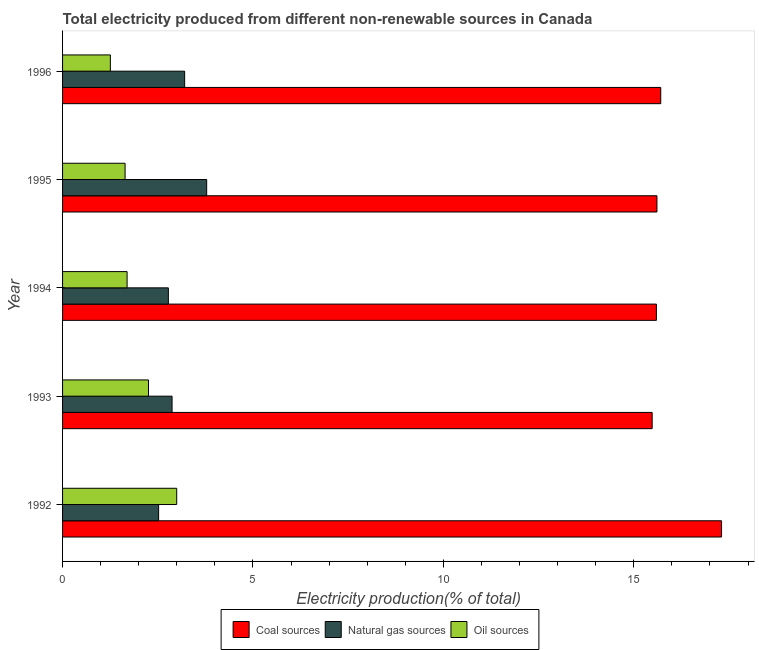How many groups of bars are there?
Offer a very short reply. 5. Are the number of bars on each tick of the Y-axis equal?
Give a very brief answer. Yes. How many bars are there on the 4th tick from the bottom?
Provide a short and direct response. 3. What is the label of the 3rd group of bars from the top?
Ensure brevity in your answer.  1994. In how many cases, is the number of bars for a given year not equal to the number of legend labels?
Make the answer very short. 0. What is the percentage of electricity produced by natural gas in 1996?
Provide a succinct answer. 3.21. Across all years, what is the maximum percentage of electricity produced by natural gas?
Provide a succinct answer. 3.78. Across all years, what is the minimum percentage of electricity produced by natural gas?
Make the answer very short. 2.52. In which year was the percentage of electricity produced by natural gas maximum?
Keep it short and to the point. 1995. What is the total percentage of electricity produced by natural gas in the graph?
Offer a very short reply. 15.16. What is the difference between the percentage of electricity produced by oil sources in 1992 and that in 1993?
Offer a very short reply. 0.74. What is the difference between the percentage of electricity produced by oil sources in 1994 and the percentage of electricity produced by natural gas in 1995?
Your answer should be compact. -2.09. What is the average percentage of electricity produced by oil sources per year?
Your answer should be very brief. 1.97. In the year 1993, what is the difference between the percentage of electricity produced by natural gas and percentage of electricity produced by coal?
Ensure brevity in your answer.  -12.61. What is the ratio of the percentage of electricity produced by natural gas in 1992 to that in 1996?
Your answer should be very brief. 0.79. What is the difference between the highest and the second highest percentage of electricity produced by oil sources?
Make the answer very short. 0.74. What is the difference between the highest and the lowest percentage of electricity produced by natural gas?
Keep it short and to the point. 1.26. In how many years, is the percentage of electricity produced by coal greater than the average percentage of electricity produced by coal taken over all years?
Your answer should be compact. 1. What does the 1st bar from the top in 1993 represents?
Offer a very short reply. Oil sources. What does the 3rd bar from the bottom in 1995 represents?
Offer a very short reply. Oil sources. Is it the case that in every year, the sum of the percentage of electricity produced by coal and percentage of electricity produced by natural gas is greater than the percentage of electricity produced by oil sources?
Ensure brevity in your answer.  Yes. How many bars are there?
Your answer should be compact. 15. What is the difference between two consecutive major ticks on the X-axis?
Your answer should be very brief. 5. Does the graph contain grids?
Offer a very short reply. No. How are the legend labels stacked?
Ensure brevity in your answer.  Horizontal. What is the title of the graph?
Provide a short and direct response. Total electricity produced from different non-renewable sources in Canada. Does "Slovak Republic" appear as one of the legend labels in the graph?
Offer a very short reply. No. What is the label or title of the Y-axis?
Ensure brevity in your answer.  Year. What is the Electricity production(% of total) in Coal sources in 1992?
Provide a short and direct response. 17.3. What is the Electricity production(% of total) in Natural gas sources in 1992?
Your response must be concise. 2.52. What is the Electricity production(% of total) in Oil sources in 1992?
Give a very brief answer. 3. What is the Electricity production(% of total) in Coal sources in 1993?
Offer a terse response. 15.48. What is the Electricity production(% of total) in Natural gas sources in 1993?
Your response must be concise. 2.88. What is the Electricity production(% of total) in Oil sources in 1993?
Make the answer very short. 2.26. What is the Electricity production(% of total) of Coal sources in 1994?
Ensure brevity in your answer.  15.59. What is the Electricity production(% of total) of Natural gas sources in 1994?
Your answer should be compact. 2.78. What is the Electricity production(% of total) of Oil sources in 1994?
Your answer should be compact. 1.69. What is the Electricity production(% of total) in Coal sources in 1995?
Provide a succinct answer. 15.61. What is the Electricity production(% of total) of Natural gas sources in 1995?
Provide a succinct answer. 3.78. What is the Electricity production(% of total) of Oil sources in 1995?
Give a very brief answer. 1.64. What is the Electricity production(% of total) in Coal sources in 1996?
Your response must be concise. 15.71. What is the Electricity production(% of total) of Natural gas sources in 1996?
Give a very brief answer. 3.21. What is the Electricity production(% of total) in Oil sources in 1996?
Offer a terse response. 1.25. Across all years, what is the maximum Electricity production(% of total) in Coal sources?
Provide a short and direct response. 17.3. Across all years, what is the maximum Electricity production(% of total) in Natural gas sources?
Your answer should be compact. 3.78. Across all years, what is the maximum Electricity production(% of total) in Oil sources?
Your response must be concise. 3. Across all years, what is the minimum Electricity production(% of total) of Coal sources?
Offer a terse response. 15.48. Across all years, what is the minimum Electricity production(% of total) of Natural gas sources?
Your answer should be very brief. 2.52. Across all years, what is the minimum Electricity production(% of total) in Oil sources?
Make the answer very short. 1.25. What is the total Electricity production(% of total) in Coal sources in the graph?
Your answer should be very brief. 79.7. What is the total Electricity production(% of total) of Natural gas sources in the graph?
Your response must be concise. 15.16. What is the total Electricity production(% of total) of Oil sources in the graph?
Keep it short and to the point. 9.85. What is the difference between the Electricity production(% of total) in Coal sources in 1992 and that in 1993?
Give a very brief answer. 1.82. What is the difference between the Electricity production(% of total) of Natural gas sources in 1992 and that in 1993?
Make the answer very short. -0.35. What is the difference between the Electricity production(% of total) of Oil sources in 1992 and that in 1993?
Your response must be concise. 0.74. What is the difference between the Electricity production(% of total) of Coal sources in 1992 and that in 1994?
Give a very brief answer. 1.71. What is the difference between the Electricity production(% of total) of Natural gas sources in 1992 and that in 1994?
Provide a succinct answer. -0.26. What is the difference between the Electricity production(% of total) in Oil sources in 1992 and that in 1994?
Your response must be concise. 1.3. What is the difference between the Electricity production(% of total) in Coal sources in 1992 and that in 1995?
Provide a short and direct response. 1.7. What is the difference between the Electricity production(% of total) in Natural gas sources in 1992 and that in 1995?
Provide a short and direct response. -1.26. What is the difference between the Electricity production(% of total) in Oil sources in 1992 and that in 1995?
Offer a terse response. 1.36. What is the difference between the Electricity production(% of total) in Coal sources in 1992 and that in 1996?
Your response must be concise. 1.6. What is the difference between the Electricity production(% of total) of Natural gas sources in 1992 and that in 1996?
Your answer should be compact. -0.68. What is the difference between the Electricity production(% of total) of Oil sources in 1992 and that in 1996?
Ensure brevity in your answer.  1.74. What is the difference between the Electricity production(% of total) in Coal sources in 1993 and that in 1994?
Your answer should be very brief. -0.11. What is the difference between the Electricity production(% of total) in Natural gas sources in 1993 and that in 1994?
Give a very brief answer. 0.1. What is the difference between the Electricity production(% of total) of Oil sources in 1993 and that in 1994?
Provide a short and direct response. 0.56. What is the difference between the Electricity production(% of total) of Coal sources in 1993 and that in 1995?
Offer a terse response. -0.13. What is the difference between the Electricity production(% of total) of Natural gas sources in 1993 and that in 1995?
Your answer should be compact. -0.91. What is the difference between the Electricity production(% of total) in Oil sources in 1993 and that in 1995?
Your response must be concise. 0.61. What is the difference between the Electricity production(% of total) in Coal sources in 1993 and that in 1996?
Give a very brief answer. -0.23. What is the difference between the Electricity production(% of total) of Natural gas sources in 1993 and that in 1996?
Provide a succinct answer. -0.33. What is the difference between the Electricity production(% of total) of Coal sources in 1994 and that in 1995?
Give a very brief answer. -0.01. What is the difference between the Electricity production(% of total) of Natural gas sources in 1994 and that in 1995?
Offer a very short reply. -1.01. What is the difference between the Electricity production(% of total) in Oil sources in 1994 and that in 1995?
Provide a succinct answer. 0.05. What is the difference between the Electricity production(% of total) of Coal sources in 1994 and that in 1996?
Your answer should be very brief. -0.11. What is the difference between the Electricity production(% of total) in Natural gas sources in 1994 and that in 1996?
Provide a short and direct response. -0.43. What is the difference between the Electricity production(% of total) of Oil sources in 1994 and that in 1996?
Provide a short and direct response. 0.44. What is the difference between the Electricity production(% of total) in Coal sources in 1995 and that in 1996?
Give a very brief answer. -0.1. What is the difference between the Electricity production(% of total) in Natural gas sources in 1995 and that in 1996?
Your answer should be compact. 0.58. What is the difference between the Electricity production(% of total) in Oil sources in 1995 and that in 1996?
Provide a short and direct response. 0.39. What is the difference between the Electricity production(% of total) in Coal sources in 1992 and the Electricity production(% of total) in Natural gas sources in 1993?
Offer a terse response. 14.43. What is the difference between the Electricity production(% of total) of Coal sources in 1992 and the Electricity production(% of total) of Oil sources in 1993?
Your response must be concise. 15.05. What is the difference between the Electricity production(% of total) of Natural gas sources in 1992 and the Electricity production(% of total) of Oil sources in 1993?
Give a very brief answer. 0.27. What is the difference between the Electricity production(% of total) in Coal sources in 1992 and the Electricity production(% of total) in Natural gas sources in 1994?
Keep it short and to the point. 14.53. What is the difference between the Electricity production(% of total) in Coal sources in 1992 and the Electricity production(% of total) in Oil sources in 1994?
Ensure brevity in your answer.  15.61. What is the difference between the Electricity production(% of total) in Natural gas sources in 1992 and the Electricity production(% of total) in Oil sources in 1994?
Offer a terse response. 0.83. What is the difference between the Electricity production(% of total) in Coal sources in 1992 and the Electricity production(% of total) in Natural gas sources in 1995?
Offer a very short reply. 13.52. What is the difference between the Electricity production(% of total) in Coal sources in 1992 and the Electricity production(% of total) in Oil sources in 1995?
Your answer should be compact. 15.66. What is the difference between the Electricity production(% of total) in Natural gas sources in 1992 and the Electricity production(% of total) in Oil sources in 1995?
Keep it short and to the point. 0.88. What is the difference between the Electricity production(% of total) of Coal sources in 1992 and the Electricity production(% of total) of Natural gas sources in 1996?
Offer a terse response. 14.1. What is the difference between the Electricity production(% of total) of Coal sources in 1992 and the Electricity production(% of total) of Oil sources in 1996?
Ensure brevity in your answer.  16.05. What is the difference between the Electricity production(% of total) of Natural gas sources in 1992 and the Electricity production(% of total) of Oil sources in 1996?
Your answer should be compact. 1.27. What is the difference between the Electricity production(% of total) in Coal sources in 1993 and the Electricity production(% of total) in Natural gas sources in 1994?
Offer a very short reply. 12.7. What is the difference between the Electricity production(% of total) of Coal sources in 1993 and the Electricity production(% of total) of Oil sources in 1994?
Offer a very short reply. 13.79. What is the difference between the Electricity production(% of total) of Natural gas sources in 1993 and the Electricity production(% of total) of Oil sources in 1994?
Ensure brevity in your answer.  1.18. What is the difference between the Electricity production(% of total) in Coal sources in 1993 and the Electricity production(% of total) in Natural gas sources in 1995?
Keep it short and to the point. 11.7. What is the difference between the Electricity production(% of total) of Coal sources in 1993 and the Electricity production(% of total) of Oil sources in 1995?
Keep it short and to the point. 13.84. What is the difference between the Electricity production(% of total) of Natural gas sources in 1993 and the Electricity production(% of total) of Oil sources in 1995?
Your answer should be compact. 1.23. What is the difference between the Electricity production(% of total) in Coal sources in 1993 and the Electricity production(% of total) in Natural gas sources in 1996?
Make the answer very short. 12.28. What is the difference between the Electricity production(% of total) of Coal sources in 1993 and the Electricity production(% of total) of Oil sources in 1996?
Your answer should be very brief. 14.23. What is the difference between the Electricity production(% of total) of Natural gas sources in 1993 and the Electricity production(% of total) of Oil sources in 1996?
Make the answer very short. 1.62. What is the difference between the Electricity production(% of total) of Coal sources in 1994 and the Electricity production(% of total) of Natural gas sources in 1995?
Keep it short and to the point. 11.81. What is the difference between the Electricity production(% of total) of Coal sources in 1994 and the Electricity production(% of total) of Oil sources in 1995?
Keep it short and to the point. 13.95. What is the difference between the Electricity production(% of total) of Natural gas sources in 1994 and the Electricity production(% of total) of Oil sources in 1995?
Keep it short and to the point. 1.14. What is the difference between the Electricity production(% of total) of Coal sources in 1994 and the Electricity production(% of total) of Natural gas sources in 1996?
Offer a terse response. 12.39. What is the difference between the Electricity production(% of total) of Coal sources in 1994 and the Electricity production(% of total) of Oil sources in 1996?
Make the answer very short. 14.34. What is the difference between the Electricity production(% of total) in Natural gas sources in 1994 and the Electricity production(% of total) in Oil sources in 1996?
Ensure brevity in your answer.  1.52. What is the difference between the Electricity production(% of total) in Coal sources in 1995 and the Electricity production(% of total) in Natural gas sources in 1996?
Offer a terse response. 12.4. What is the difference between the Electricity production(% of total) in Coal sources in 1995 and the Electricity production(% of total) in Oil sources in 1996?
Offer a terse response. 14.35. What is the difference between the Electricity production(% of total) in Natural gas sources in 1995 and the Electricity production(% of total) in Oil sources in 1996?
Ensure brevity in your answer.  2.53. What is the average Electricity production(% of total) in Coal sources per year?
Offer a very short reply. 15.94. What is the average Electricity production(% of total) of Natural gas sources per year?
Ensure brevity in your answer.  3.03. What is the average Electricity production(% of total) of Oil sources per year?
Ensure brevity in your answer.  1.97. In the year 1992, what is the difference between the Electricity production(% of total) of Coal sources and Electricity production(% of total) of Natural gas sources?
Keep it short and to the point. 14.78. In the year 1992, what is the difference between the Electricity production(% of total) of Coal sources and Electricity production(% of total) of Oil sources?
Provide a succinct answer. 14.31. In the year 1992, what is the difference between the Electricity production(% of total) in Natural gas sources and Electricity production(% of total) in Oil sources?
Your answer should be very brief. -0.48. In the year 1993, what is the difference between the Electricity production(% of total) of Coal sources and Electricity production(% of total) of Natural gas sources?
Your response must be concise. 12.61. In the year 1993, what is the difference between the Electricity production(% of total) in Coal sources and Electricity production(% of total) in Oil sources?
Give a very brief answer. 13.23. In the year 1993, what is the difference between the Electricity production(% of total) of Natural gas sources and Electricity production(% of total) of Oil sources?
Provide a succinct answer. 0.62. In the year 1994, what is the difference between the Electricity production(% of total) of Coal sources and Electricity production(% of total) of Natural gas sources?
Give a very brief answer. 12.82. In the year 1994, what is the difference between the Electricity production(% of total) of Coal sources and Electricity production(% of total) of Oil sources?
Provide a short and direct response. 13.9. In the year 1994, what is the difference between the Electricity production(% of total) of Natural gas sources and Electricity production(% of total) of Oil sources?
Give a very brief answer. 1.08. In the year 1995, what is the difference between the Electricity production(% of total) of Coal sources and Electricity production(% of total) of Natural gas sources?
Your answer should be very brief. 11.82. In the year 1995, what is the difference between the Electricity production(% of total) of Coal sources and Electricity production(% of total) of Oil sources?
Your response must be concise. 13.97. In the year 1995, what is the difference between the Electricity production(% of total) in Natural gas sources and Electricity production(% of total) in Oil sources?
Your answer should be very brief. 2.14. In the year 1996, what is the difference between the Electricity production(% of total) in Coal sources and Electricity production(% of total) in Natural gas sources?
Offer a terse response. 12.5. In the year 1996, what is the difference between the Electricity production(% of total) of Coal sources and Electricity production(% of total) of Oil sources?
Provide a short and direct response. 14.45. In the year 1996, what is the difference between the Electricity production(% of total) in Natural gas sources and Electricity production(% of total) in Oil sources?
Provide a short and direct response. 1.95. What is the ratio of the Electricity production(% of total) in Coal sources in 1992 to that in 1993?
Keep it short and to the point. 1.12. What is the ratio of the Electricity production(% of total) of Natural gas sources in 1992 to that in 1993?
Provide a succinct answer. 0.88. What is the ratio of the Electricity production(% of total) in Oil sources in 1992 to that in 1993?
Give a very brief answer. 1.33. What is the ratio of the Electricity production(% of total) of Coal sources in 1992 to that in 1994?
Your answer should be compact. 1.11. What is the ratio of the Electricity production(% of total) of Natural gas sources in 1992 to that in 1994?
Make the answer very short. 0.91. What is the ratio of the Electricity production(% of total) in Oil sources in 1992 to that in 1994?
Offer a terse response. 1.77. What is the ratio of the Electricity production(% of total) of Coal sources in 1992 to that in 1995?
Give a very brief answer. 1.11. What is the ratio of the Electricity production(% of total) in Natural gas sources in 1992 to that in 1995?
Provide a succinct answer. 0.67. What is the ratio of the Electricity production(% of total) of Oil sources in 1992 to that in 1995?
Offer a terse response. 1.83. What is the ratio of the Electricity production(% of total) in Coal sources in 1992 to that in 1996?
Keep it short and to the point. 1.1. What is the ratio of the Electricity production(% of total) of Natural gas sources in 1992 to that in 1996?
Provide a short and direct response. 0.79. What is the ratio of the Electricity production(% of total) of Oil sources in 1992 to that in 1996?
Give a very brief answer. 2.39. What is the ratio of the Electricity production(% of total) in Natural gas sources in 1993 to that in 1994?
Your answer should be very brief. 1.03. What is the ratio of the Electricity production(% of total) of Oil sources in 1993 to that in 1994?
Offer a terse response. 1.33. What is the ratio of the Electricity production(% of total) of Coal sources in 1993 to that in 1995?
Offer a terse response. 0.99. What is the ratio of the Electricity production(% of total) in Natural gas sources in 1993 to that in 1995?
Your answer should be very brief. 0.76. What is the ratio of the Electricity production(% of total) in Oil sources in 1993 to that in 1995?
Offer a terse response. 1.37. What is the ratio of the Electricity production(% of total) in Coal sources in 1993 to that in 1996?
Ensure brevity in your answer.  0.99. What is the ratio of the Electricity production(% of total) in Natural gas sources in 1993 to that in 1996?
Your answer should be compact. 0.9. What is the ratio of the Electricity production(% of total) in Oil sources in 1993 to that in 1996?
Your response must be concise. 1.8. What is the ratio of the Electricity production(% of total) in Natural gas sources in 1994 to that in 1995?
Your answer should be compact. 0.73. What is the ratio of the Electricity production(% of total) of Oil sources in 1994 to that in 1995?
Ensure brevity in your answer.  1.03. What is the ratio of the Electricity production(% of total) of Natural gas sources in 1994 to that in 1996?
Keep it short and to the point. 0.87. What is the ratio of the Electricity production(% of total) of Oil sources in 1994 to that in 1996?
Make the answer very short. 1.35. What is the ratio of the Electricity production(% of total) in Coal sources in 1995 to that in 1996?
Make the answer very short. 0.99. What is the ratio of the Electricity production(% of total) of Natural gas sources in 1995 to that in 1996?
Offer a very short reply. 1.18. What is the ratio of the Electricity production(% of total) of Oil sources in 1995 to that in 1996?
Your response must be concise. 1.31. What is the difference between the highest and the second highest Electricity production(% of total) in Coal sources?
Ensure brevity in your answer.  1.6. What is the difference between the highest and the second highest Electricity production(% of total) of Natural gas sources?
Your response must be concise. 0.58. What is the difference between the highest and the second highest Electricity production(% of total) in Oil sources?
Your response must be concise. 0.74. What is the difference between the highest and the lowest Electricity production(% of total) of Coal sources?
Your response must be concise. 1.82. What is the difference between the highest and the lowest Electricity production(% of total) in Natural gas sources?
Keep it short and to the point. 1.26. What is the difference between the highest and the lowest Electricity production(% of total) in Oil sources?
Offer a very short reply. 1.74. 